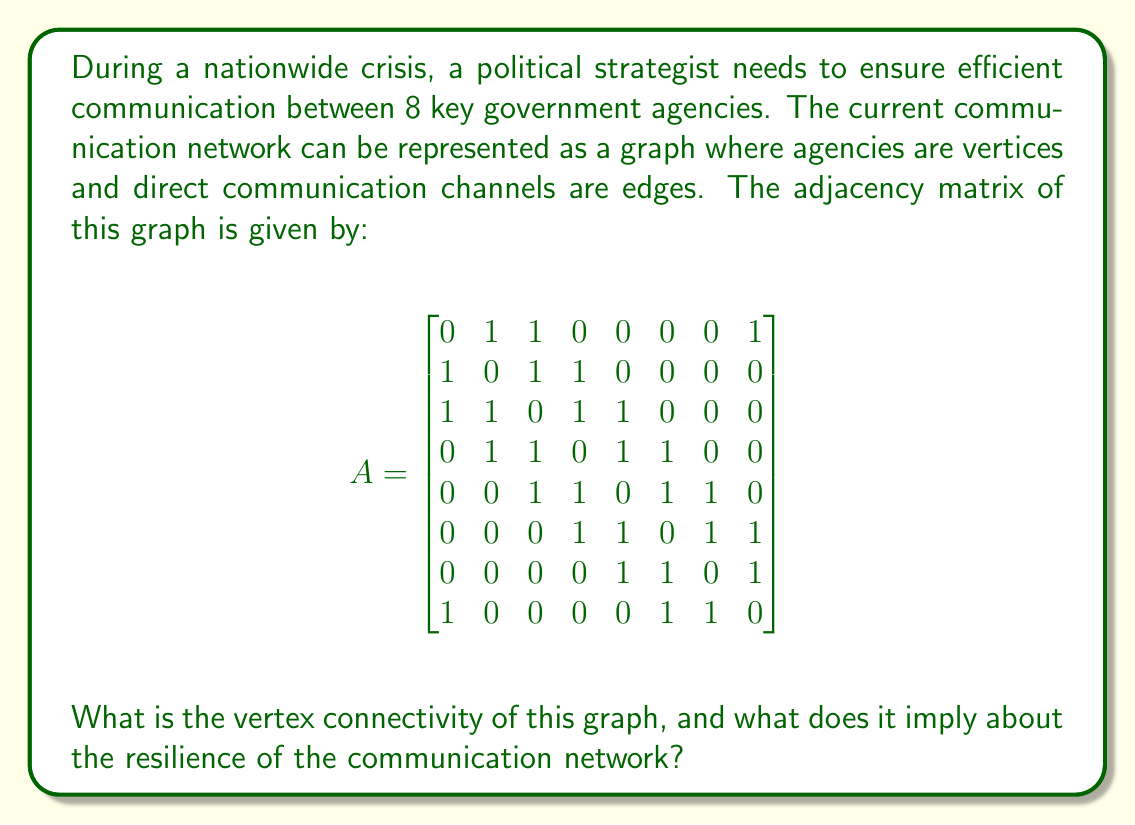What is the answer to this math problem? To solve this problem, we need to understand the concept of vertex connectivity and how to calculate it from the given adjacency matrix.

1) Vertex connectivity $\kappa(G)$ of a graph G is the minimum number of vertices that need to be removed to disconnect the graph.

2) To find the vertex connectivity, we can use Menger's theorem, which states that the vertex connectivity is equal to the minimum number of vertex-disjoint paths between any two non-adjacent vertices.

3) From the adjacency matrix, we can see that vertices 1 and 5 are non-adjacent. Let's find the minimum number of vertex-disjoint paths between them:

   Path 1: 1 - 2 - 4 - 5
   Path 2: 1 - 3 - 5
   Path 3: 1 - 8 - 6 - 5

4) We can verify that there are no more than 3 vertex-disjoint paths between any other pair of non-adjacent vertices.

5) Therefore, the vertex connectivity of this graph is 3.

6) This implies that at least 3 agencies (vertices) need to be removed to disconnect the communication network. In other words, the network can withstand the failure of any 2 agencies and still remain connected.

7) In terms of network resilience, this means:
   - The communication network is relatively robust.
   - There are multiple redundant paths for information to flow between agencies.
   - The network can maintain overall connectivity even if two agencies become non-operational.

8) However, it also highlights that the loss of three strategically chosen agencies could severely disrupt the entire communication network, which is crucial information for crisis management planning.
Answer: The vertex connectivity of the graph is 3. This implies that the communication network is relatively resilient, able to maintain connectivity even if two agencies fail, but could be severely disrupted if three strategically chosen agencies become non-operational. 